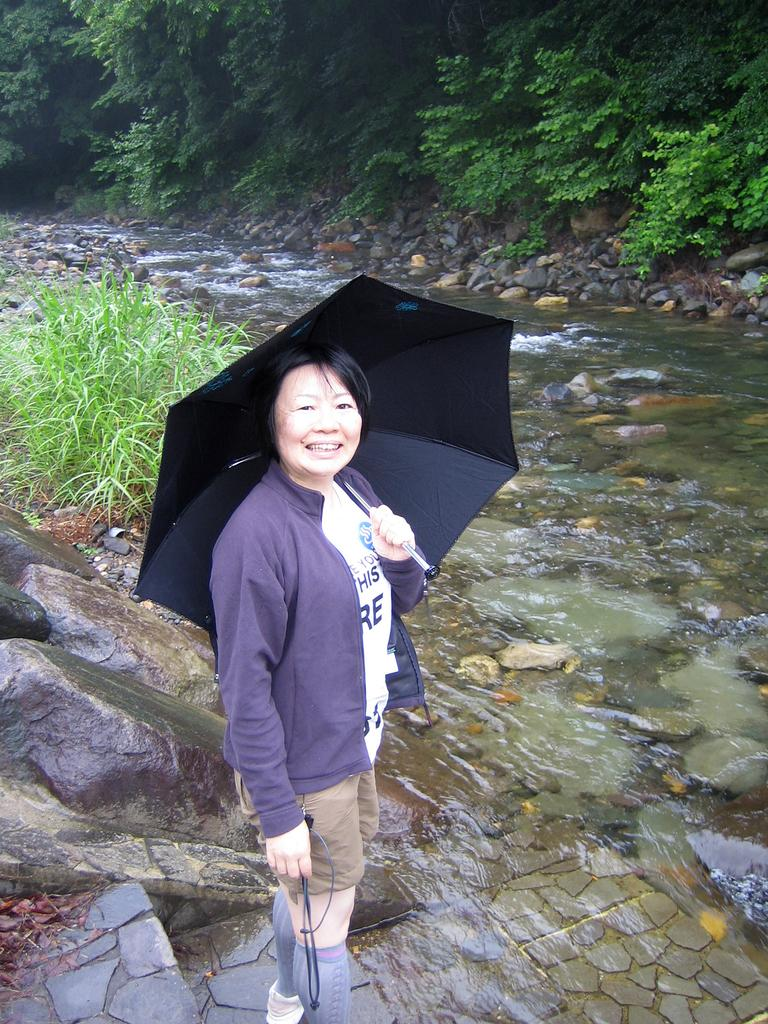What is the person in the image holding? The person is holding an umbrella in the image. What can be seen in the center of the image? There is water in the center of the image. What type of natural feature is present in the image? There are rocks in the image. What can be seen in the background of the image? There are trees in the background of the image. What type of zinc is present in the image? There is no zinc present in the image. What route is the person taking in the image? The image does not provide information about the person's route or direction. 